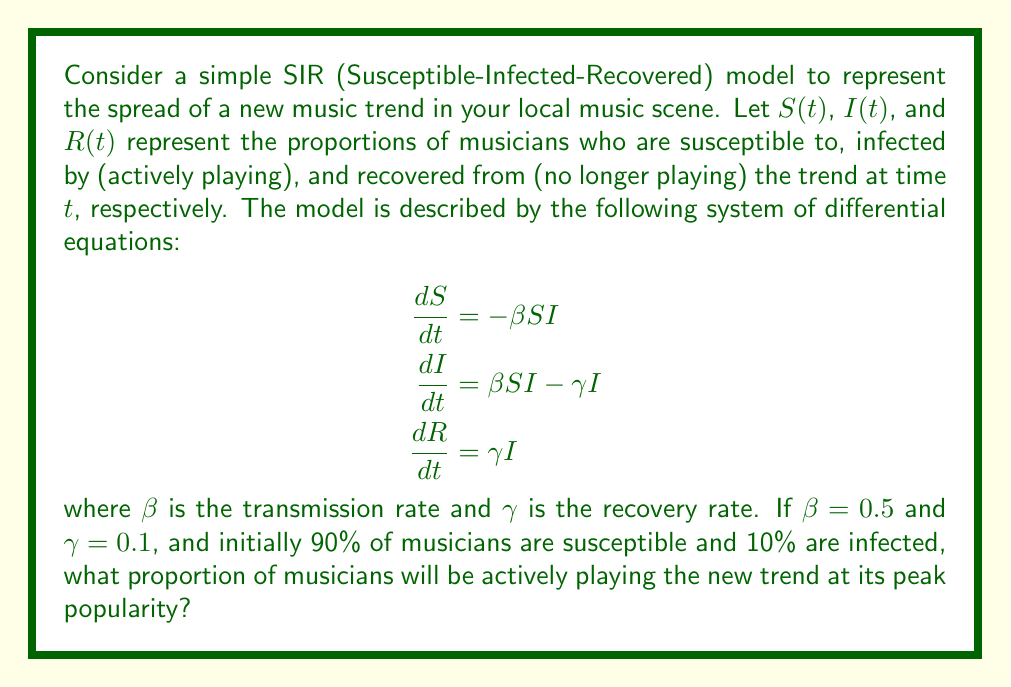Could you help me with this problem? To solve this problem, we need to follow these steps:

1) First, we need to determine when the trend reaches its peak popularity. This occurs when $\frac{dI}{dt} = 0$.

2) From the equation for $\frac{dI}{dt}$, we can see that this happens when:

   $\beta SI - \gamma I = 0$
   $SI = \frac{\gamma}{\beta}$

3) We're given that $\beta = 0.5$ and $\gamma = 0.1$, so:

   $SI = \frac{0.1}{0.5} = 0.2$

4) We also know that $S + I + R = 1$ at all times. At the start, $S(0) = 0.9$ and $I(0) = 0.1$.

5) To find $S$ at the peak, we can use the conservation equation:

   $\frac{dS}{dI} = -\frac{S}{\gamma} = -\frac{S}{0.1}$

6) Integrating both sides:

   $\ln(S) = -10I + C$

   Where $C$ is a constant. We can find $C$ using the initial conditions:

   $\ln(0.9) = -10(0.1) + C$
   $C = \ln(0.9) + 1 = 1.9459$

7) Now we can write an equation for $S$ in terms of $I$:

   $S = e^{-10I + 1.9459}$

8) Substituting this into the equation from step 3:

   $e^{-10I + 1.9459} \cdot I = 0.2$

9) This equation can be solved numerically to give $I \approx 0.2716$.

Therefore, at the peak of the trend's popularity, approximately 27.16% of musicians will be actively playing it.
Answer: The proportion of musicians actively playing the new trend at its peak popularity is approximately 0.2716 or 27.16%. 